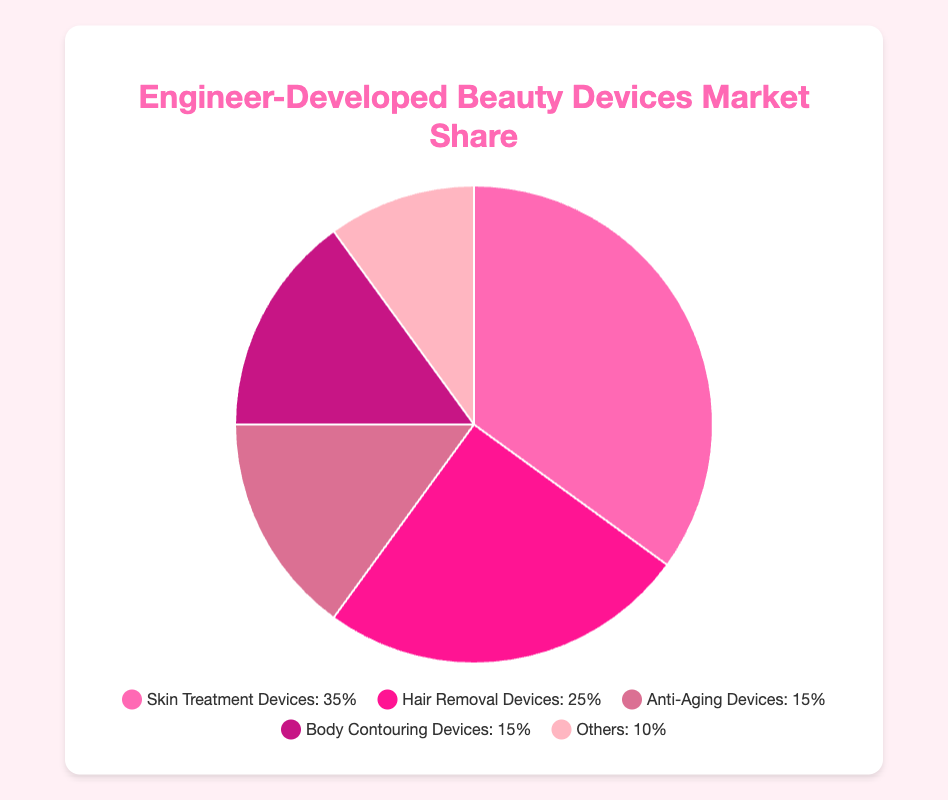what percentage of the market share do Skin Treatment Devices and Hair Removal Devices hold together? To find the combined market share of Skin Treatment Devices and Hair Removal Devices, add their individual percentages: 35% + 25% = 60%.
Answer: 60% what percentage more market share do Skin Treatment Devices hold compared to Anti-Aging Devices? Skin Treatment Devices hold 35% and Anti-Aging Devices hold 15%. The difference in their market shares is 35% - 15% = 20%.
Answer: 20% Which device type has the lowest market share? From the pie chart, the device type labeled "Others" has the lowest market share at 10%.
Answer: Others Which device types have equal market share? Anti-Aging Devices and Body Contouring Devices both have a market share of 15%.
Answer: Anti-Aging Devices and Body Contouring Devices What portion of the total market share is not occupied by Skin Treatment Devices and Hair Removal Devices? First, calculate the combined market share of Skin Treatment Devices and Hair Removal Devices: 35% + 25% = 60%. Subtract this from the total 100% to find the remaining portion: 100% - 60% = 40%.
Answer: 40% Which type of devices holds the second-largest market share, and what is that percentage? After Skin Treatment Devices, Hair Removal Devices hold the second-largest market share at 25%.
Answer: Hair Removal Devices, 25% How many categories of devices have a market share greater than or equal to 15%? The categories are Skin Treatment Devices (35%), Hair Removal Devices (25%), Anti-Aging Devices (15%), and Body Contouring Devices (15%). There are 4 categories.
Answer: 4 Which device type is represented by the color closest to red? From the description of the dataset colors, Hair Removal Devices have the market share represented by a color described as "#FF1493", which is closest to red.
Answer: Hair Removal Devices What's the average market share percentage of Anti-Aging Devices, Body Contouring Devices, and Others? Add the percentages of the three types: 15% (Anti-Aging) + 15% (Body Contouring) + 10% (Others) = 40%. Divide this sum by 3: 40% / 3 ≈ 13.33%.
Answer: 13.33% What is the total market share percentage for devices categorized as Body Contouring Devices and Others? Add the market share percentages of Body Contouring Devices (15%) and Others (10%): 15% + 10% = 25%.
Answer: 25% 